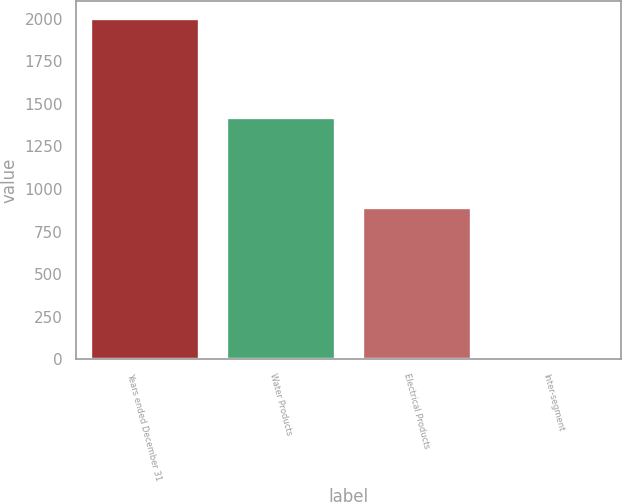<chart> <loc_0><loc_0><loc_500><loc_500><bar_chart><fcel>Years ended December 31<fcel>Water Products<fcel>Electrical Products<fcel>Inter-segment<nl><fcel>2007<fcel>1423.1<fcel>894<fcel>5<nl></chart> 